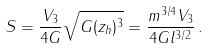Convert formula to latex. <formula><loc_0><loc_0><loc_500><loc_500>S = \frac { V _ { 3 } } { 4 G } \sqrt { G ( z _ { h } ) ^ { 3 } } = \frac { m ^ { 3 / 4 } V _ { 3 } } { 4 G l ^ { 3 / 2 } } \, .</formula> 